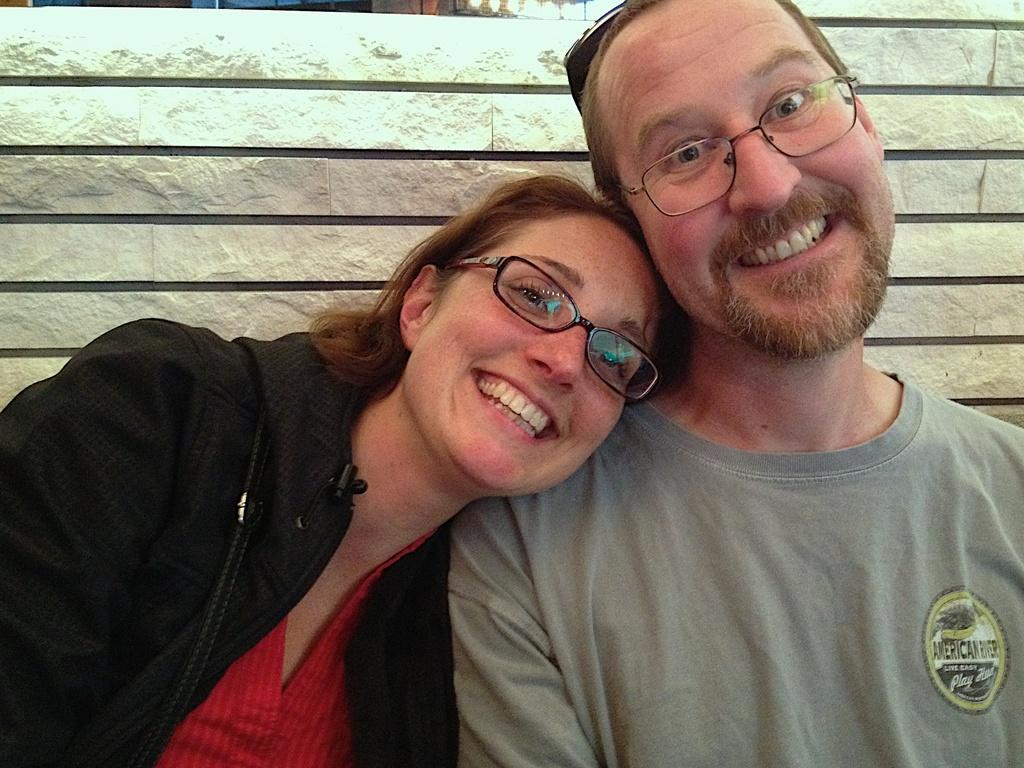How would you summarize this image in a sentence or two? In this picture there is a woman places her head on the shoulder of a person beside her and there is a fence wall behind them. 